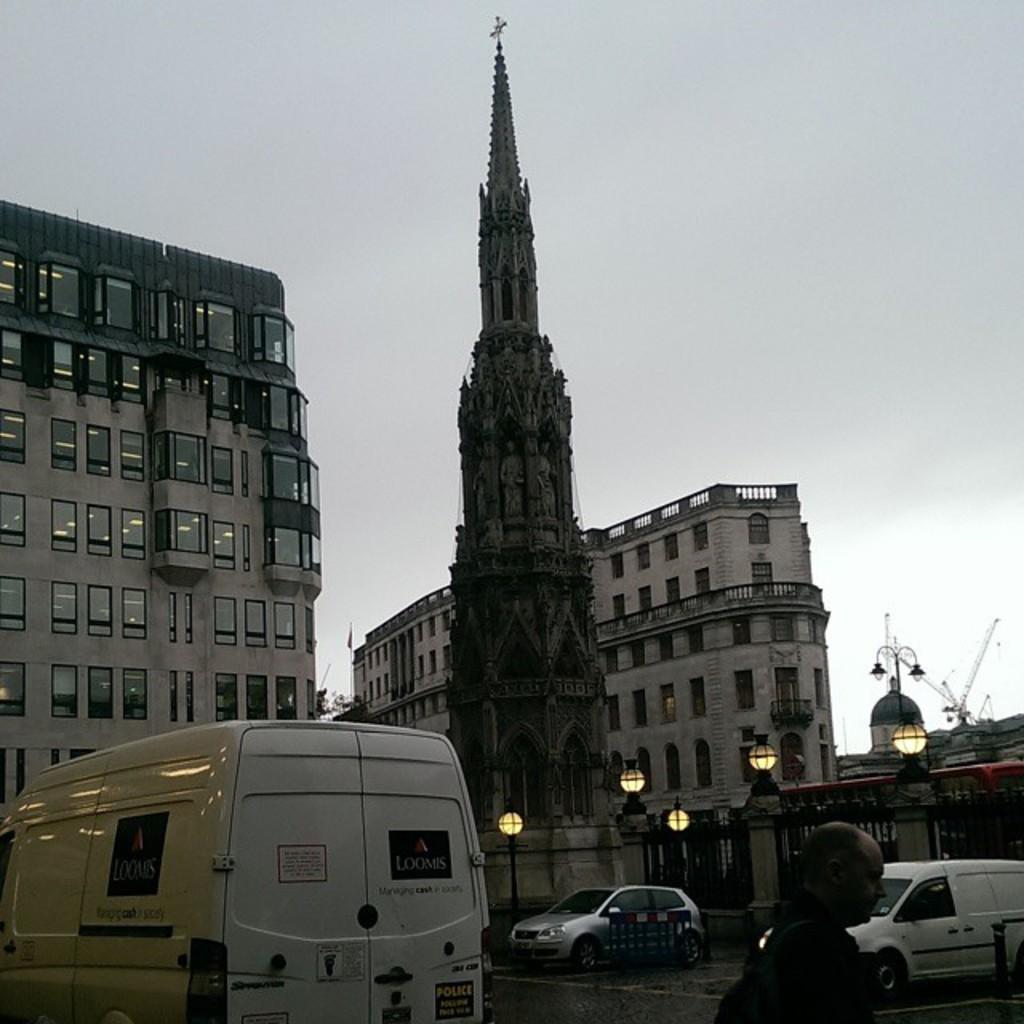Can you describe this image briefly? In this image in the front is a person. In the center there are vehicles moving on the road, there are poles, gates. In the background there are buildings and there is a tower and the sky is cloudy. 